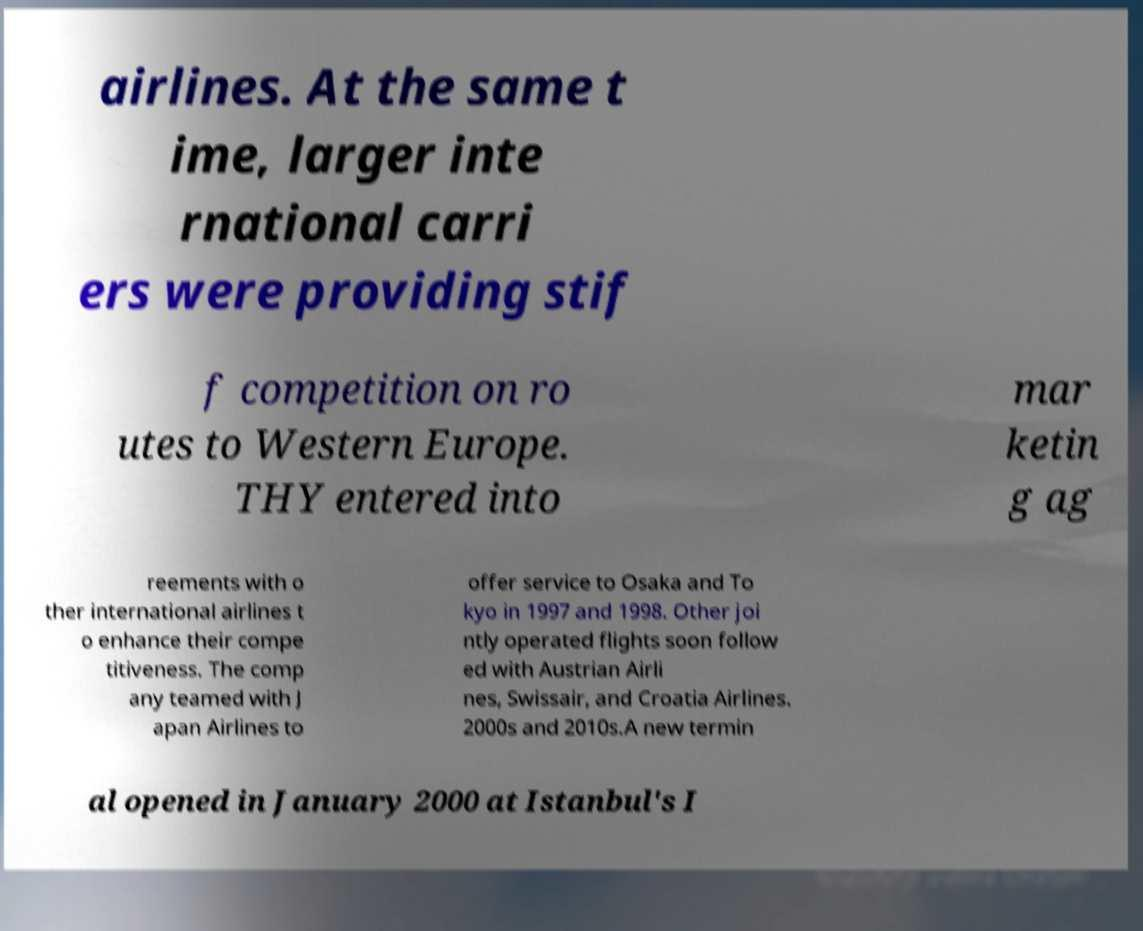Could you assist in decoding the text presented in this image and type it out clearly? airlines. At the same t ime, larger inte rnational carri ers were providing stif f competition on ro utes to Western Europe. THY entered into mar ketin g ag reements with o ther international airlines t o enhance their compe titiveness. The comp any teamed with J apan Airlines to offer service to Osaka and To kyo in 1997 and 1998. Other joi ntly operated flights soon follow ed with Austrian Airli nes, Swissair, and Croatia Airlines. 2000s and 2010s.A new termin al opened in January 2000 at Istanbul's I 